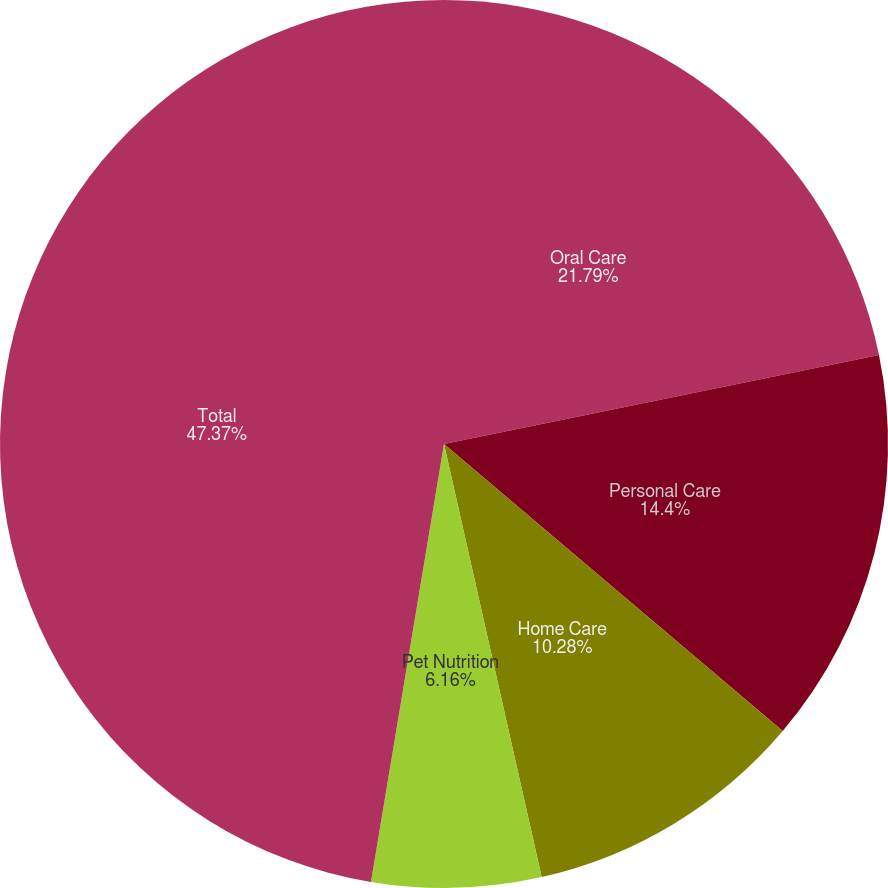<chart> <loc_0><loc_0><loc_500><loc_500><pie_chart><fcel>Oral Care<fcel>Personal Care<fcel>Home Care<fcel>Pet Nutrition<fcel>Total<nl><fcel>21.79%<fcel>14.4%<fcel>10.28%<fcel>6.16%<fcel>47.37%<nl></chart> 